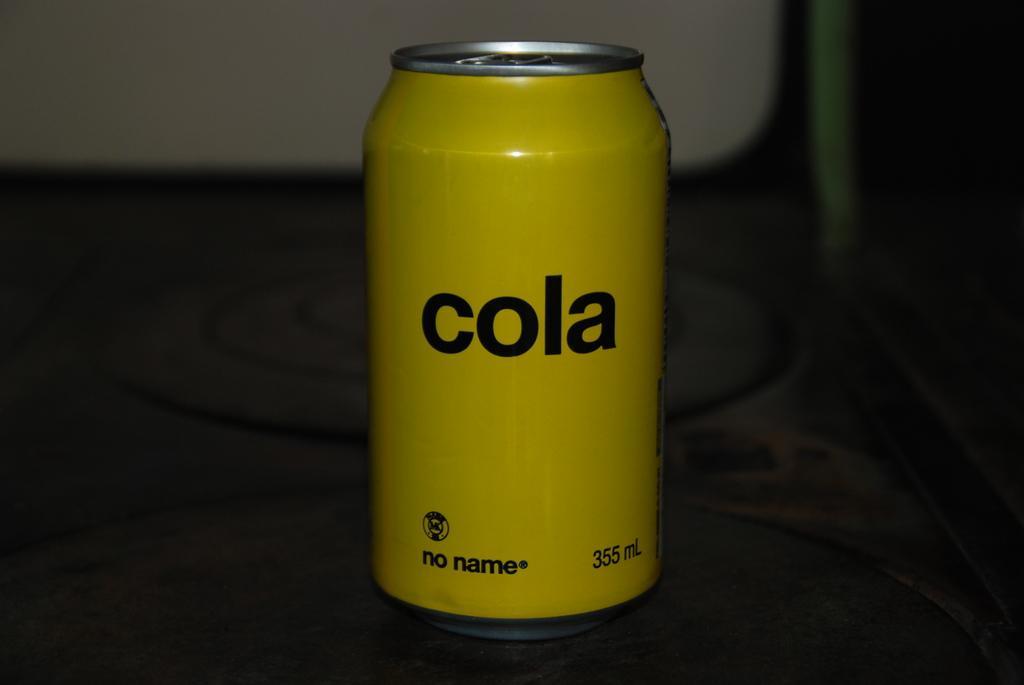Can you describe this image briefly? This is a zoomed in picture. In the center there is a yellow color can placed on an object and we can see the text and the numbers on the can. In the background there is an object seems to be the wall. 